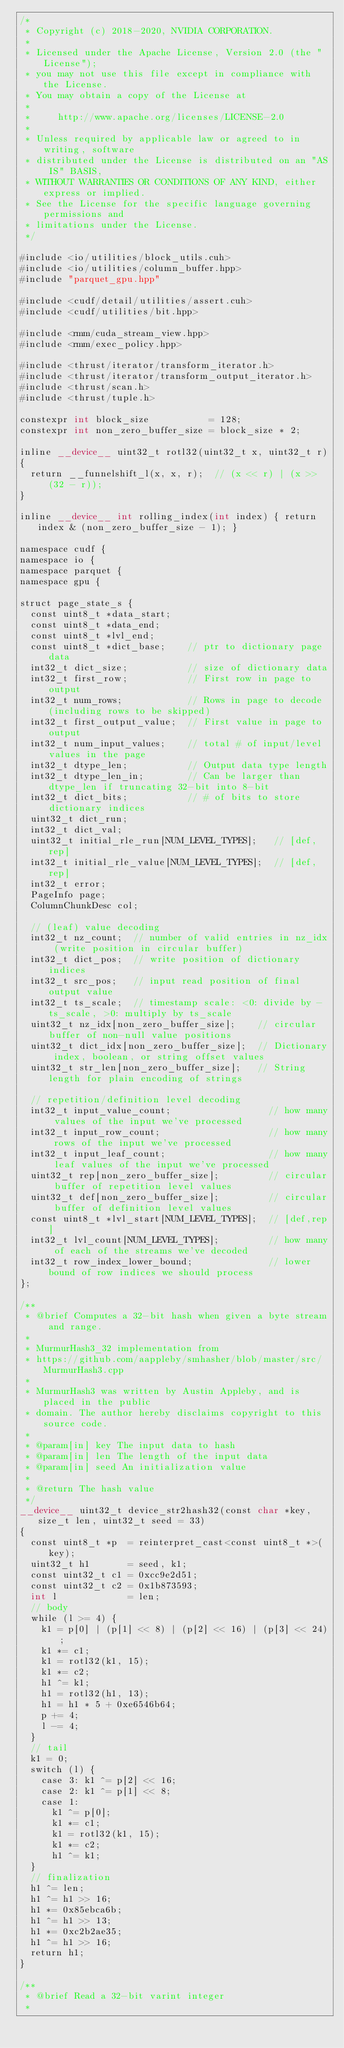Convert code to text. <code><loc_0><loc_0><loc_500><loc_500><_Cuda_>/*
 * Copyright (c) 2018-2020, NVIDIA CORPORATION.
 *
 * Licensed under the Apache License, Version 2.0 (the "License");
 * you may not use this file except in compliance with the License.
 * You may obtain a copy of the License at
 *
 *     http://www.apache.org/licenses/LICENSE-2.0
 *
 * Unless required by applicable law or agreed to in writing, software
 * distributed under the License is distributed on an "AS IS" BASIS,
 * WITHOUT WARRANTIES OR CONDITIONS OF ANY KIND, either express or implied.
 * See the License for the specific language governing permissions and
 * limitations under the License.
 */

#include <io/utilities/block_utils.cuh>
#include <io/utilities/column_buffer.hpp>
#include "parquet_gpu.hpp"

#include <cudf/detail/utilities/assert.cuh>
#include <cudf/utilities/bit.hpp>

#include <rmm/cuda_stream_view.hpp>
#include <rmm/exec_policy.hpp>

#include <thrust/iterator/transform_iterator.h>
#include <thrust/iterator/transform_output_iterator.h>
#include <thrust/scan.h>
#include <thrust/tuple.h>

constexpr int block_size           = 128;
constexpr int non_zero_buffer_size = block_size * 2;

inline __device__ uint32_t rotl32(uint32_t x, uint32_t r)
{
  return __funnelshift_l(x, x, r);  // (x << r) | (x >> (32 - r));
}

inline __device__ int rolling_index(int index) { return index & (non_zero_buffer_size - 1); }

namespace cudf {
namespace io {
namespace parquet {
namespace gpu {

struct page_state_s {
  const uint8_t *data_start;
  const uint8_t *data_end;
  const uint8_t *lvl_end;
  const uint8_t *dict_base;    // ptr to dictionary page data
  int32_t dict_size;           // size of dictionary data
  int32_t first_row;           // First row in page to output
  int32_t num_rows;            // Rows in page to decode (including rows to be skipped)
  int32_t first_output_value;  // First value in page to output
  int32_t num_input_values;    // total # of input/level values in the page
  int32_t dtype_len;           // Output data type length
  int32_t dtype_len_in;        // Can be larger than dtype_len if truncating 32-bit into 8-bit
  int32_t dict_bits;           // # of bits to store dictionary indices
  uint32_t dict_run;
  int32_t dict_val;
  uint32_t initial_rle_run[NUM_LEVEL_TYPES];   // [def,rep]
  int32_t initial_rle_value[NUM_LEVEL_TYPES];  // [def,rep]
  int32_t error;
  PageInfo page;
  ColumnChunkDesc col;

  // (leaf) value decoding
  int32_t nz_count;  // number of valid entries in nz_idx (write position in circular buffer)
  int32_t dict_pos;  // write position of dictionary indices
  int32_t src_pos;   // input read position of final output value
  int32_t ts_scale;  // timestamp scale: <0: divide by -ts_scale, >0: multiply by ts_scale
  uint32_t nz_idx[non_zero_buffer_size];    // circular buffer of non-null value positions
  uint32_t dict_idx[non_zero_buffer_size];  // Dictionary index, boolean, or string offset values
  uint32_t str_len[non_zero_buffer_size];   // String length for plain encoding of strings

  // repetition/definition level decoding
  int32_t input_value_count;                  // how many values of the input we've processed
  int32_t input_row_count;                    // how many rows of the input we've processed
  int32_t input_leaf_count;                   // how many leaf values of the input we've processed
  uint32_t rep[non_zero_buffer_size];         // circular buffer of repetition level values
  uint32_t def[non_zero_buffer_size];         // circular buffer of definition level values
  const uint8_t *lvl_start[NUM_LEVEL_TYPES];  // [def,rep]
  int32_t lvl_count[NUM_LEVEL_TYPES];         // how many of each of the streams we've decoded
  int32_t row_index_lower_bound;              // lower bound of row indices we should process
};

/**
 * @brief Computes a 32-bit hash when given a byte stream and range.
 *
 * MurmurHash3_32 implementation from
 * https://github.com/aappleby/smhasher/blob/master/src/MurmurHash3.cpp
 *
 * MurmurHash3 was written by Austin Appleby, and is placed in the public
 * domain. The author hereby disclaims copyright to this source code.
 *
 * @param[in] key The input data to hash
 * @param[in] len The length of the input data
 * @param[in] seed An initialization value
 *
 * @return The hash value
 */
__device__ uint32_t device_str2hash32(const char *key, size_t len, uint32_t seed = 33)
{
  const uint8_t *p  = reinterpret_cast<const uint8_t *>(key);
  uint32_t h1       = seed, k1;
  const uint32_t c1 = 0xcc9e2d51;
  const uint32_t c2 = 0x1b873593;
  int l             = len;
  // body
  while (l >= 4) {
    k1 = p[0] | (p[1] << 8) | (p[2] << 16) | (p[3] << 24);
    k1 *= c1;
    k1 = rotl32(k1, 15);
    k1 *= c2;
    h1 ^= k1;
    h1 = rotl32(h1, 13);
    h1 = h1 * 5 + 0xe6546b64;
    p += 4;
    l -= 4;
  }
  // tail
  k1 = 0;
  switch (l) {
    case 3: k1 ^= p[2] << 16;
    case 2: k1 ^= p[1] << 8;
    case 1:
      k1 ^= p[0];
      k1 *= c1;
      k1 = rotl32(k1, 15);
      k1 *= c2;
      h1 ^= k1;
  }
  // finalization
  h1 ^= len;
  h1 ^= h1 >> 16;
  h1 *= 0x85ebca6b;
  h1 ^= h1 >> 13;
  h1 *= 0xc2b2ae35;
  h1 ^= h1 >> 16;
  return h1;
}

/**
 * @brief Read a 32-bit varint integer
 *</code> 